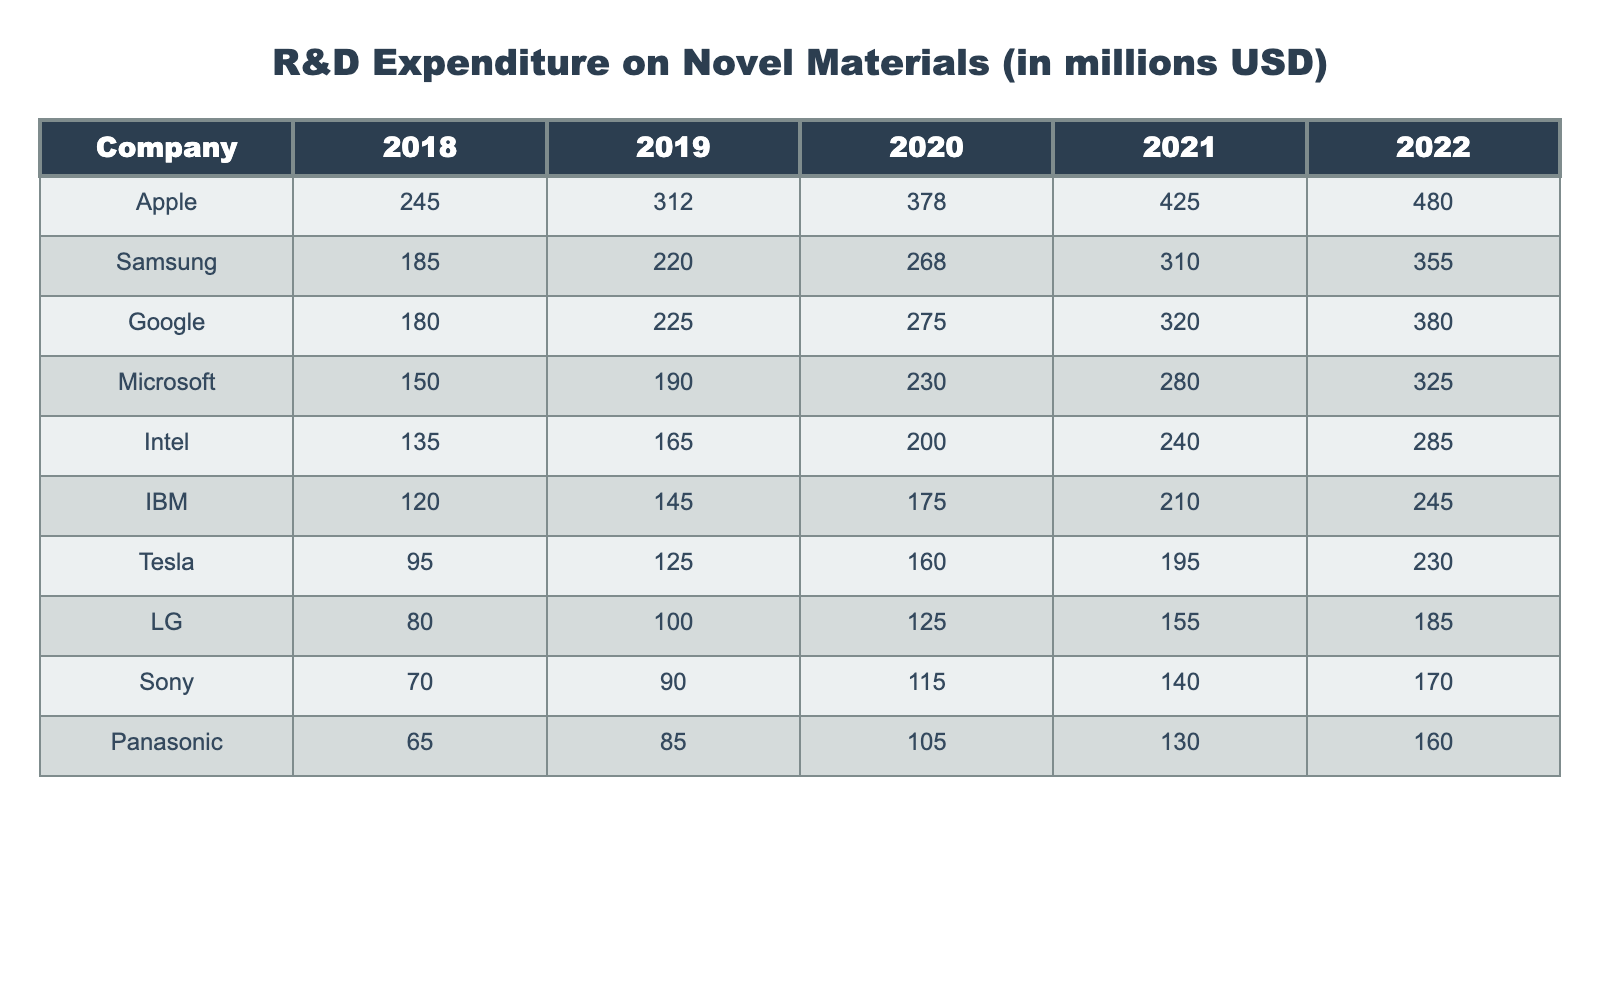What was Apple's R&D expenditure in 2020? Refer to the row for Apple in the 2020 column, which shows the value of 378 million USD.
Answer: 378 million USD Which company had the highest R&D expenditure in 2022? Looking at the 2022 column, Apple has the highest value of 480 million USD compared to all other companies listed.
Answer: Apple What is the total R&D expenditure of Samsung and LG from 2018 to 2022? Sum the values for Samsung (185 + 220 + 268 + 310 + 355 = 1338) and LG (80 + 100 + 125 + 155 + 185 = 645), giving a total of 1338 + 645 = 1983 million USD.
Answer: 1983 million USD What was the year-over-year growth percentage of Google’s R&D expenditure from 2021 to 2022? The expenditure increased from 320 million USD in 2021 to 380 million USD in 2022. The growth is (380 - 320) / 320 * 100 = 18.75%.
Answer: 18.75% Which two companies had the smallest R&D expenditures in 2018 and what were their amounts? The two companies at the bottom of the 2018 column are Panasonic (65 million USD) and Sony (70 million USD).
Answer: Panasonic and Sony, 65 million USD and 70 million USD respectively Did Intel’s R&D expenditure increase every year? Checking Intel's values from 2018 to 2022, they increased consistently from 135 to 285 million USD, with no decline.
Answer: Yes What was the average R&D expenditure of all companies in 2021? Calculate the expenditures for 2021: (425 + 310 + 320 + 280 + 240 + 210 + 195 + 155 + 140 + 130) = 2,640 million USD, then divide by 10 companies to get an average of 264 million USD.
Answer: 264 million USD Which company had the largest increase in expenditure from 2019 to 2020? Calculate the increase for each company: Apple (66), Samsung (48), Google (50), Microsoft (40), Intel (35), IBM (30), Tesla (35), LG (25), Sony (25), Panasonic (20). Apple had the highest increase of 66 million USD.
Answer: Apple What was the total R&D expenditure of all companies in 2022? Sum up the expenditures in the 2022 column: (480 + 355 + 380 + 325 + 285 + 245 + 230 + 185 + 170 + 160) = 2,785 million USD.
Answer: 2,785 million USD Was there a time when IBM's expenditures were lower than Intel's? Reviewing the values, IBM's expenditure (120, 145, 175, 210, 245) never fell below Intel's (135, 165, 200, 240, 285) in those years.
Answer: No 